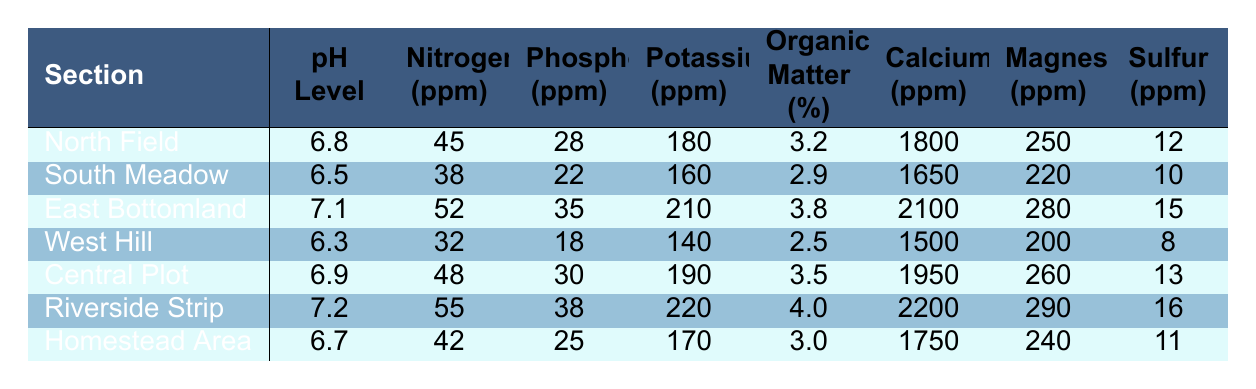What is the pH level of the Riverside Strip? The table shows the pH levels for each section. The Riverside Strip has a pH level of 7.2.
Answer: 7.2 Which section has the highest Nitrogen content? By reviewing the Nitrogen (ppm) values in the table, the Riverside Strip has the highest Nitrogen content at 55 ppm.
Answer: Riverside Strip What is the average Potassium level across all sections? To find the average Potassium level, sum all Potassium values (180 + 160 + 210 + 140 + 190 + 220 + 170 = 1280), then divide by the number of sections (7). So 1280/7 = 182.86.
Answer: 182.86 Is the Organic Matter percentage in the East Bottomland higher than in the West Hill? The table shows that the East Bottomland has 3.8% Organic Matter and the West Hill has 2.5%. Since 3.8% is greater than 2.5%, the statement is true.
Answer: Yes Which section has both the highest pH level and the highest Magnesium content? The Riverside Strip has the highest pH level (7.2) and also the highest Magnesium content (290 ppm). No other section has both these characteristics.
Answer: Riverside Strip What is the difference in Calcium content between the East Bottomland and the South Meadow? The table shows Calcium for the East Bottomland is 2100 ppm and for the South Meadow is 1650 ppm. The difference is 2100 - 1650 = 450 ppm.
Answer: 450 ppm Is there a section with more than 40 ppm of Phosphorus and an Organic Matter percentage of more than 3%? Checking the values, East Bottomland has 35 ppm Phosphorus and 3.8% Organic Matter, Riverside Strip has 38 ppm Phosphorus and 4.0% Organic Matter. Both have more than 40 ppm Phosphorus, so there is at least one section that meets the criteria.
Answer: Yes 